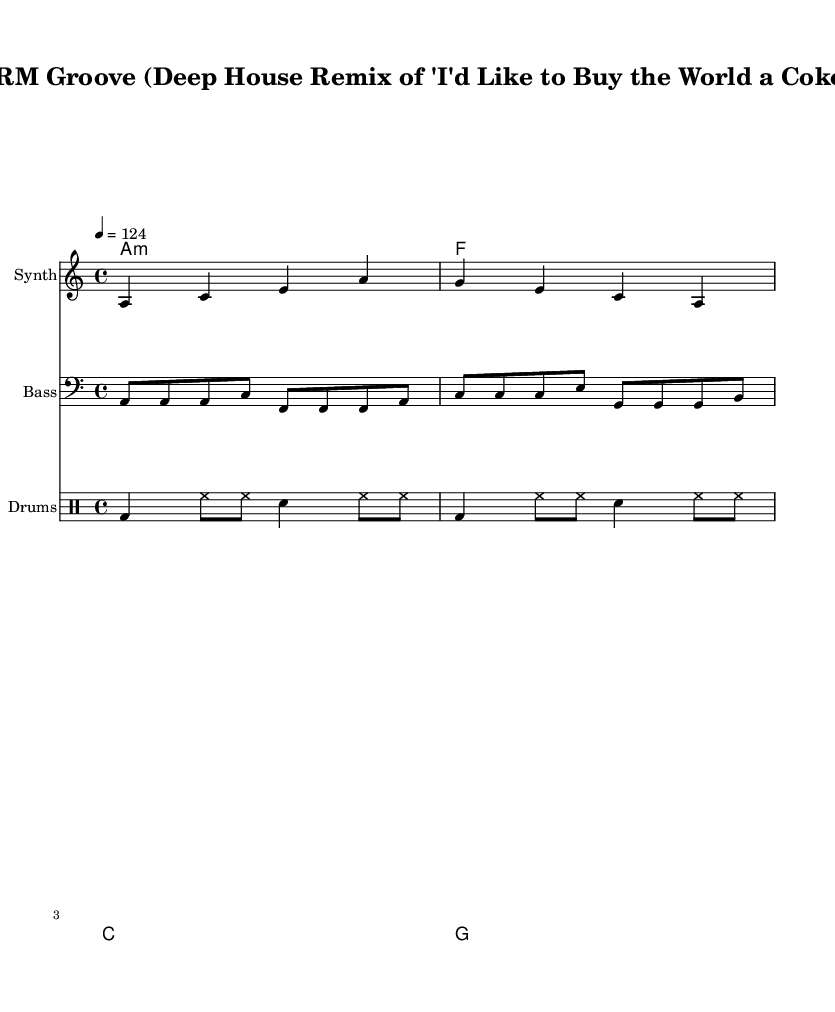What is the key signature of this music? The key signature is A minor, indicated by the absence of sharps or flats in the music and the A note being used as a tonic.
Answer: A minor What is the time signature of this piece? The time signature is 4/4, which is indicated at the beginning of the score and signifies four beats per measure.
Answer: 4/4 What is the tempo marking for this piece? The tempo marking is noted as "4 = 124," indicating the quarter note should be played at a speed of 124 beats per minute.
Answer: 124 How many measures are in the melody? There are four measures in the melody part based on the visual separation of the notes, each group of notes under the staff lines represents a measure.
Answer: 4 Which instrument is specified to play the bass line? The bass line is specified to be played by a Staff labeled as "Bass," indicated in the score layout.
Answer: Bass What kind of rhythm pattern is used in the drum section? The rhythm pattern in the drum section features a kick drum (bd) and hi-hat (hh) in a repeating sequence, typical for house music.
Answer: Repeating What is the first chord in the harmonic progression? The first chord in the harmonic progression is an A minor chord indicated at the start of the chord mode section of the score.
Answer: A minor 